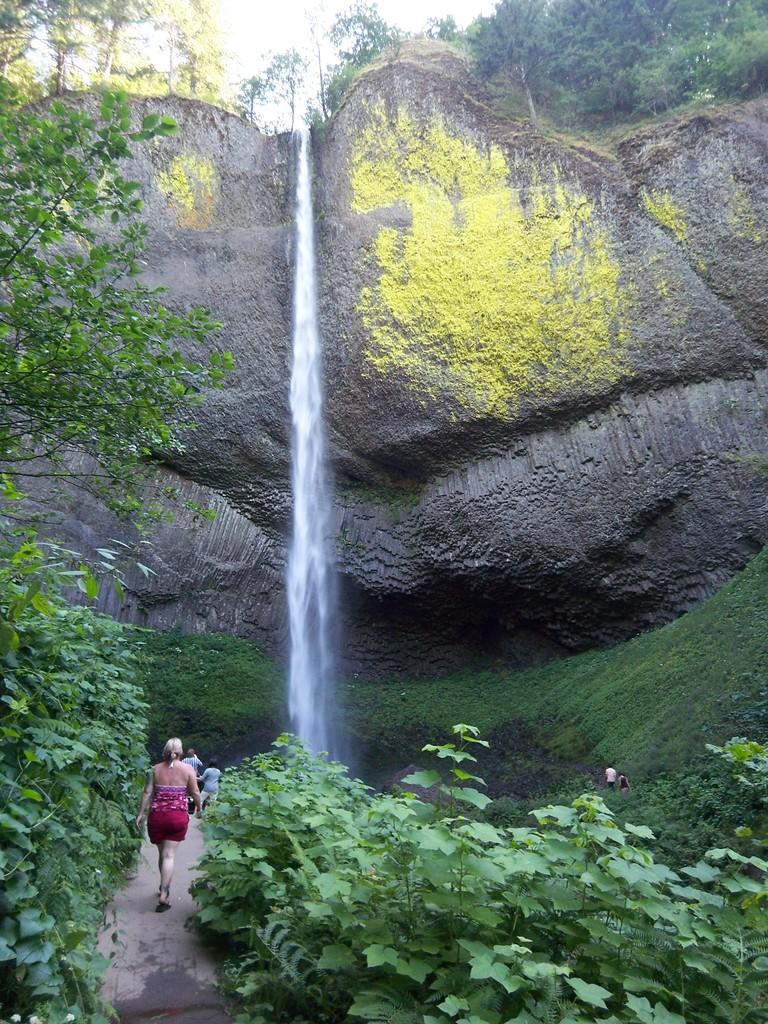How many people are in the group visible in the image? There is a group of people in the image, but the exact number cannot be determined from the provided facts. What is located near the group of people? There are plants near the group of people. What can be seen in the background of the image? There is water and trees visible in the background of the image. What type of flooring is visible beneath the group of people in the image? There is no information about the flooring in the image, as the focus is on the group of people and the surrounding plants, water, and trees. 